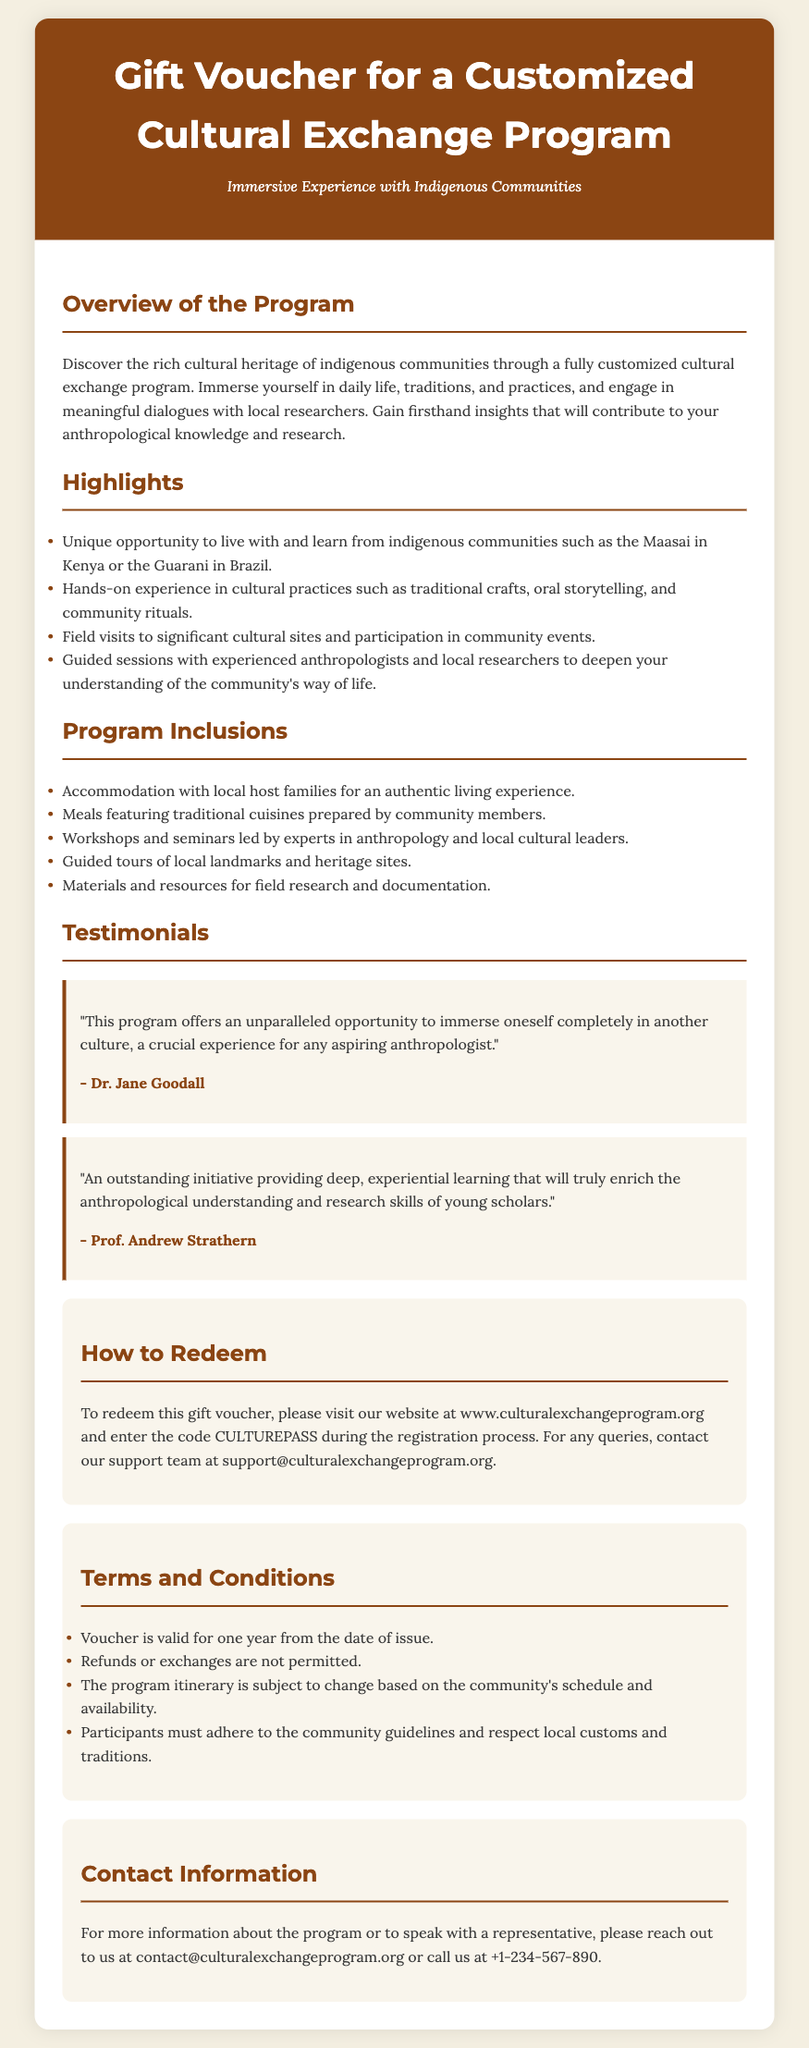What is the title of the program? The title of the program is explicitly mentioned in the header section of the document.
Answer: Gift Voucher for a Customized Cultural Exchange Program Who provided a testimonial for the program? The document lists testimonials from specific individuals in the Testimonials section, including Dr. Jane Goodall and Prof. Andrew Strathern.
Answer: Prof. Andrew Strathern What does the voucher entitle you to participate in? The Overview section describes what the voucher is for and the kind of experience it entails.
Answer: A customized cultural exchange program How long is the voucher valid? The validity of the voucher is stated in the Terms and Conditions section.
Answer: One year What are participants required to adhere to? The document specifies an expectation from participants in the Terms and Conditions section.
Answer: Community guidelines What is one cultural practice you can learn about? The Highlights section mentions hands-on experiences available to participants.
Answer: Traditional crafts How can you redeem the voucher? The instructions for redeeming the voucher are provided clearly in the How to Redeem section.
Answer: Enter the code CULTUREPASS during registration What kind of meals are included in the program? The Program Inclusions section details the types of meals participants can expect.
Answer: Traditional cuisines What should you do for queries about the program? The contact details for inquiries are provided in the Contact Information section.
Answer: Contact support team at support@culturalexchangeprogram.org 